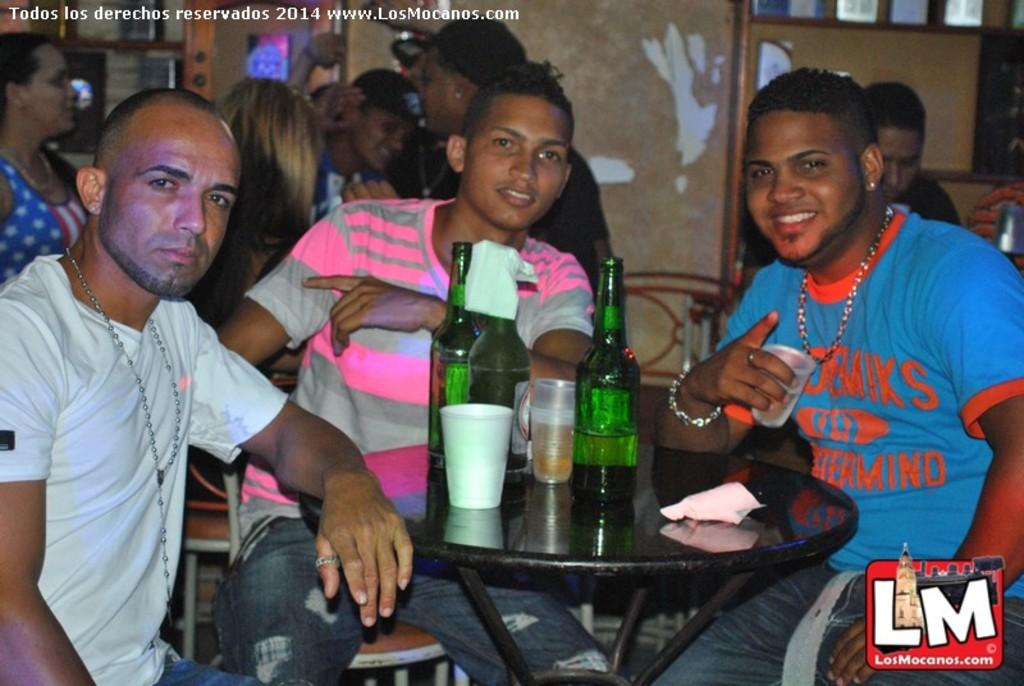What are the persons in the image doing? The persons in the image are sitting on chairs. Where are the chairs located in relation to the table? The chairs are in front of the table. What items can be seen on the table? There are bottles and glasses on the table. What can be seen in the background of the image? There are compartments visible in the background. What type of sugar is being harvested in the territory visible in the image? There is no territory or sugar harvesting visible in the image; it features persons sitting on chairs in front of a table with bottles and glasses. 